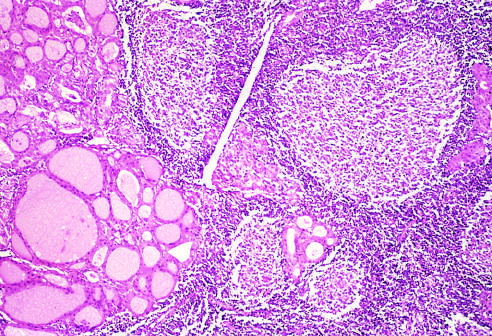does the thyroid parenchyma contain a dense lymphocytic infiltrate with germinal centers?
Answer the question using a single word or phrase. Yes 